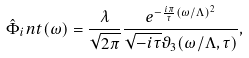Convert formula to latex. <formula><loc_0><loc_0><loc_500><loc_500>\hat { \Phi } _ { i } n t ( \omega ) = \frac { \lambda } { \sqrt { 2 \pi } } \frac { e ^ { - \frac { i \pi } { \tau } ( \omega / \Lambda ) ^ { 2 } } } { \sqrt { - i \tau } \vartheta _ { 3 } ( \omega / \Lambda , \tau ) } ,</formula> 